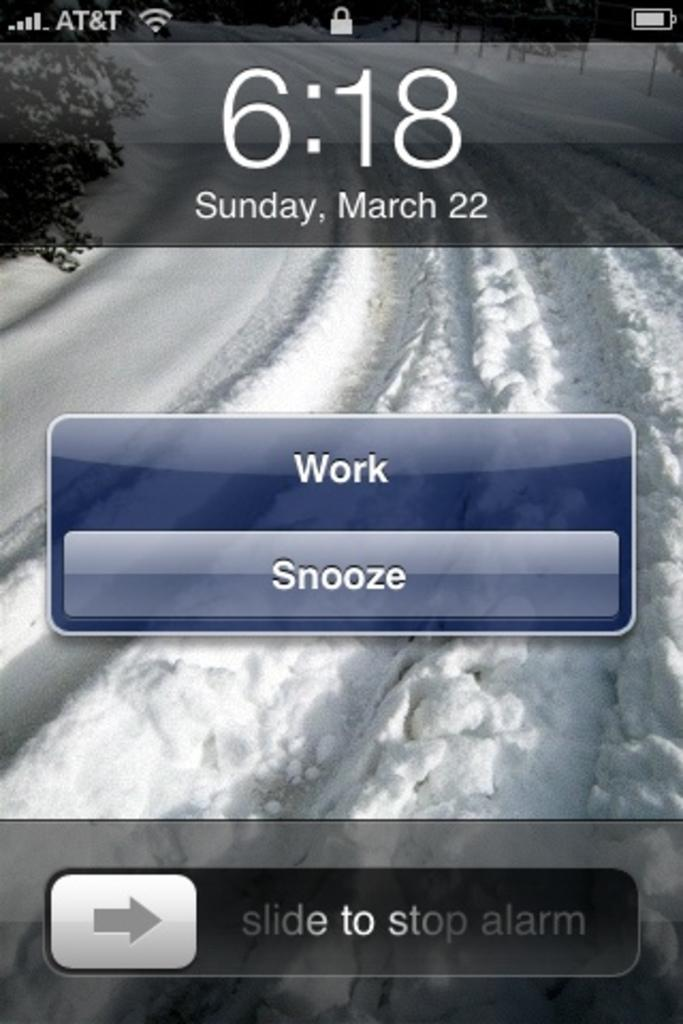<image>
Render a clear and concise summary of the photo. An alarm with a work and a snooze button 